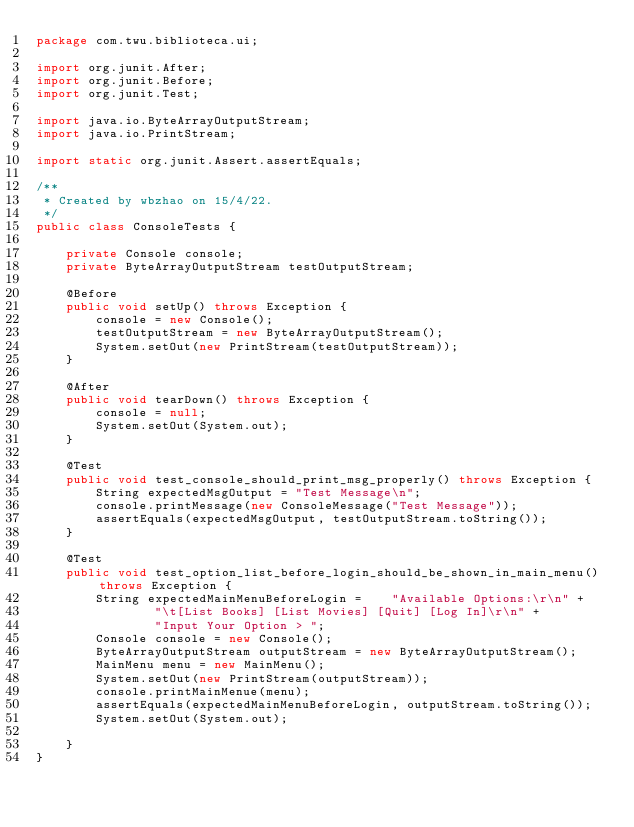Convert code to text. <code><loc_0><loc_0><loc_500><loc_500><_Java_>package com.twu.biblioteca.ui;

import org.junit.After;
import org.junit.Before;
import org.junit.Test;

import java.io.ByteArrayOutputStream;
import java.io.PrintStream;

import static org.junit.Assert.assertEquals;

/**
 * Created by wbzhao on 15/4/22.
 */
public class ConsoleTests {

    private Console console;
    private ByteArrayOutputStream testOutputStream;

    @Before
    public void setUp() throws Exception {
        console = new Console();
        testOutputStream = new ByteArrayOutputStream();
        System.setOut(new PrintStream(testOutputStream));
    }

    @After
    public void tearDown() throws Exception {
        console = null;
        System.setOut(System.out);
    }

    @Test
    public void test_console_should_print_msg_properly() throws Exception {
        String expectedMsgOutput = "Test Message\n";
        console.printMessage(new ConsoleMessage("Test Message"));
        assertEquals(expectedMsgOutput, testOutputStream.toString());
    }

    @Test
    public void test_option_list_before_login_should_be_shown_in_main_menu() throws Exception {
        String expectedMainMenuBeforeLogin =    "Available Options:\r\n" +
                "\t[List Books] [List Movies] [Quit] [Log In]\r\n" +
                "Input Your Option > ";
        Console console = new Console();
        ByteArrayOutputStream outputStream = new ByteArrayOutputStream();
        MainMenu menu = new MainMenu();
        System.setOut(new PrintStream(outputStream));
        console.printMainMenue(menu);
        assertEquals(expectedMainMenuBeforeLogin, outputStream.toString());
        System.setOut(System.out);

    }
}
</code> 